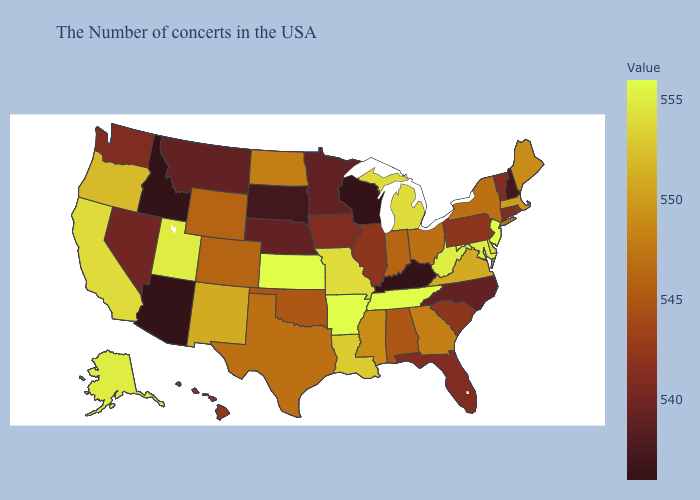Among the states that border Missouri , which have the highest value?
Keep it brief. Tennessee, Arkansas, Kansas. Does North Dakota have a lower value than New Hampshire?
Keep it brief. No. Among the states that border Tennessee , does Kentucky have the lowest value?
Short answer required. Yes. Does Montana have the lowest value in the USA?
Be succinct. No. Which states hav the highest value in the Northeast?
Quick response, please. New Jersey. Among the states that border Iowa , which have the lowest value?
Answer briefly. Wisconsin. Does the map have missing data?
Keep it brief. No. Does North Carolina have a higher value than Pennsylvania?
Write a very short answer. No. 